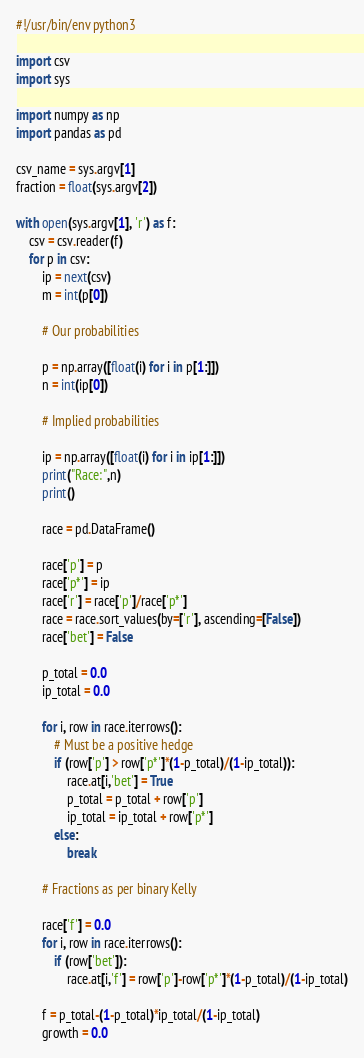Convert code to text. <code><loc_0><loc_0><loc_500><loc_500><_Python_>#!/usr/bin/env python3

import csv
import sys

import numpy as np
import pandas as pd

csv_name = sys.argv[1]
fraction = float(sys.argv[2])

with open(sys.argv[1], 'r') as f:
    csv = csv.reader(f)
    for p in csv:
        ip = next(csv)
        m = int(p[0])
        
        # Our probabilities
        
        p = np.array([float(i) for i in p[1:]])
        n = int(ip[0])

        # Implied probabilities
        
        ip = np.array([float(i) for i in ip[1:]])
        print("Race:",n)
        print()

        race = pd.DataFrame()

        race['p'] = p
        race['p*'] = ip
        race['r'] = race['p']/race['p*']
        race = race.sort_values(by=['r'], ascending=[False])
        race['bet'] = False

        p_total = 0.0
        ip_total = 0.0
        
        for i, row in race.iterrows():
            # Must be a positive hedge
            if (row['p'] > row['p*']*(1-p_total)/(1-ip_total)):
                race.at[i,'bet'] = True
                p_total = p_total + row['p']
                ip_total = ip_total + row['p*']
            else:
                break

        # Fractions as per binary Kelly

        race['f'] = 0.0
        for i, row in race.iterrows():
            if (row['bet']):
                race.at[i,'f'] = row['p']-row['p*']*(1-p_total)/(1-ip_total)

        f = p_total-(1-p_total)*ip_total/(1-ip_total)
        growth = 0.0</code> 